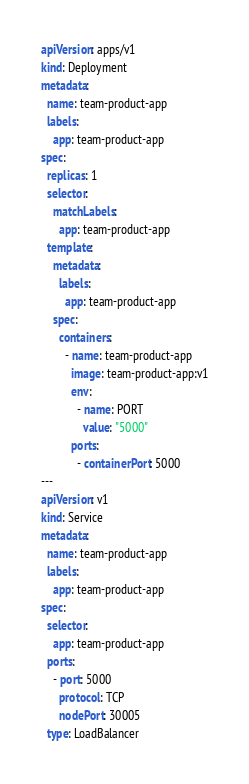Convert code to text. <code><loc_0><loc_0><loc_500><loc_500><_YAML_>apiVersion: apps/v1
kind: Deployment
metadata:
  name: team-product-app
  labels:
    app: team-product-app
spec:
  replicas: 1
  selector:
    matchLabels:
      app: team-product-app
  template:
    metadata:
      labels:
        app: team-product-app
    spec:
      containers:
        - name: team-product-app
          image: team-product-app:v1
          env:
            - name: PORT
              value: "5000"
          ports:
            - containerPort: 5000
---
apiVersion: v1
kind: Service
metadata:
  name: team-product-app
  labels:
    app: team-product-app
spec:
  selector:
    app: team-product-app
  ports:
    - port: 5000
      protocol: TCP
      nodePort: 30005
  type: LoadBalancer
</code> 